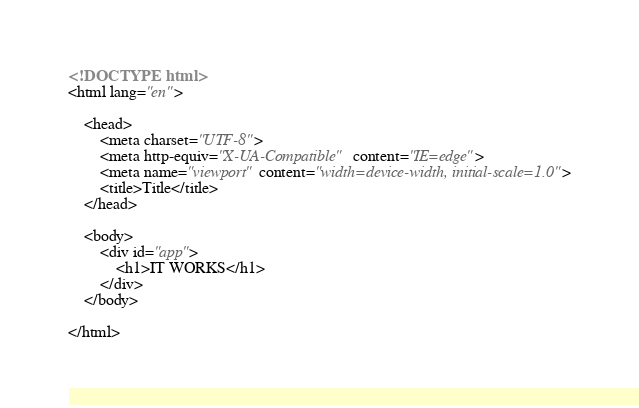Convert code to text. <code><loc_0><loc_0><loc_500><loc_500><_HTML_><!DOCTYPE html>
<html lang="en">

    <head>
        <meta charset="UTF-8">
        <meta http-equiv="X-UA-Compatible" content="IE=edge">
        <meta name="viewport" content="width=device-width, initial-scale=1.0">
        <title>Title</title>
    </head>

    <body>
        <div id="app">
            <h1>IT WORKS</h1>
        </div>
    </body>

</html>
</code> 